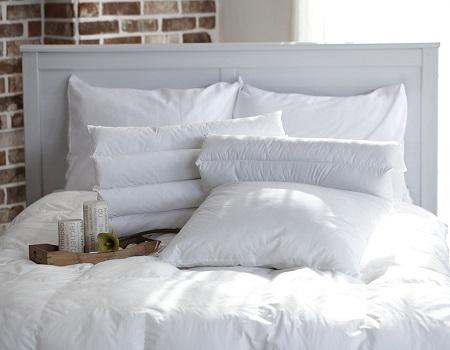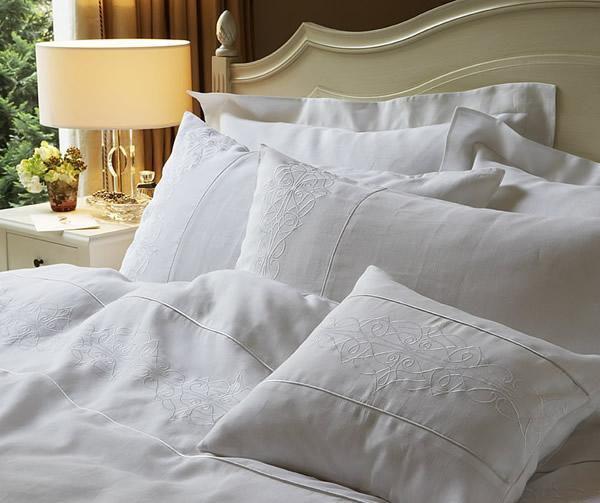The first image is the image on the left, the second image is the image on the right. Considering the images on both sides, is "The headboard in the image on the left is upholstered." valid? Answer yes or no. No. 